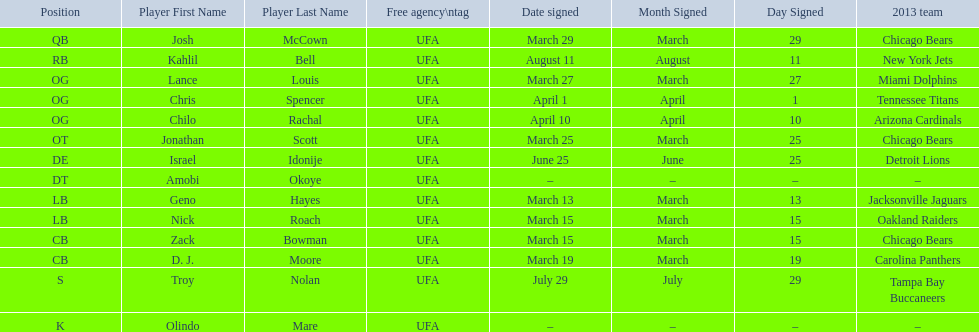The top played position according to this chart. OG. Would you mind parsing the complete table? {'header': ['Position', 'Player First Name', 'Player Last Name', 'Free agency\\ntag', 'Date signed', 'Month Signed', 'Day Signed', '2013 team'], 'rows': [['QB', 'Josh', 'McCown', 'UFA', 'March 29', 'March', '29', 'Chicago Bears'], ['RB', 'Kahlil', 'Bell', 'UFA', 'August 11', 'August', '11', 'New York Jets'], ['OG', 'Lance', 'Louis', 'UFA', 'March 27', 'March', '27', 'Miami Dolphins'], ['OG', 'Chris', 'Spencer', 'UFA', 'April 1', 'April', '1', 'Tennessee Titans'], ['OG', 'Chilo', 'Rachal', 'UFA', 'April 10', 'April', '10', 'Arizona Cardinals'], ['OT', 'Jonathan', 'Scott', 'UFA', 'March 25', 'March', '25', 'Chicago Bears'], ['DE', 'Israel', 'Idonije', 'UFA', 'June 25', 'June', '25', 'Detroit Lions'], ['DT', 'Amobi', 'Okoye', 'UFA', '–', '–', '–', '–'], ['LB', 'Geno', 'Hayes', 'UFA', 'March 13', 'March', '13', 'Jacksonville Jaguars'], ['LB', 'Nick', 'Roach', 'UFA', 'March 15', 'March', '15', 'Oakland Raiders'], ['CB', 'Zack', 'Bowman', 'UFA', 'March 15', 'March', '15', 'Chicago Bears'], ['CB', 'D. J.', 'Moore', 'UFA', 'March 19', 'March', '19', 'Carolina Panthers'], ['S', 'Troy', 'Nolan', 'UFA', 'July 29', 'July', '29', 'Tampa Bay Buccaneers'], ['K', 'Olindo', 'Mare', 'UFA', '–', '–', '–', '–']]} 